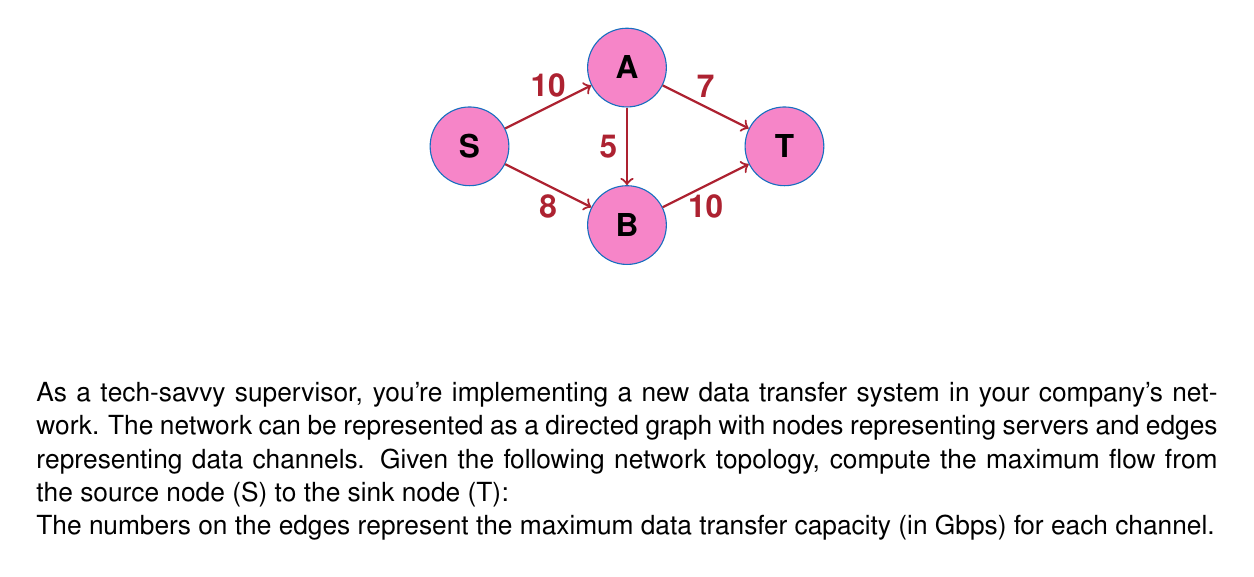Provide a solution to this math problem. To solve this problem, we'll use the Ford-Fulkerson algorithm to find the maximum flow in the network. Here's a step-by-step explanation:

1) Initialize the flow to 0 for all edges.

2) Find an augmenting path from S to T. We'll use depth-first search (DFS) for this.

3) Augment the flow along the path found in step 2.

4) Repeat steps 2 and 3 until no augmenting path can be found.

Let's go through the iterations:

Iteration 1:
Path: S -> A -> T
Bottleneck capacity: min(10, 7) = 7
Flow after augmentation: 7

Iteration 2:
Path: S -> B -> T
Bottleneck capacity: min(8, 10) = 8
Flow after augmentation: 7 + 8 = 15

Iteration 3:
Path: S -> A -> B -> T
Bottleneck capacity: min(10 - 7, 5, 10 - 8) = 2
Flow after augmentation: 15 + 2 = 17

At this point, no more augmenting paths can be found. The maximum flow is therefore 17 Gbps.

We can verify this by checking the flow conservation at each node:

At S: 7 + 8 + 2 = 17 (outflow)
At A: 7 + 2 = 9 (inflow = outflow)
At B: 8 + 2 = 10 (inflow = outflow)
At T: 7 + 8 + 2 = 17 (inflow)

The flow is conserved at all nodes, and the total flow from S equals the total flow into T, confirming our result.
Answer: The maximum flow in the given network is 17 Gbps. 